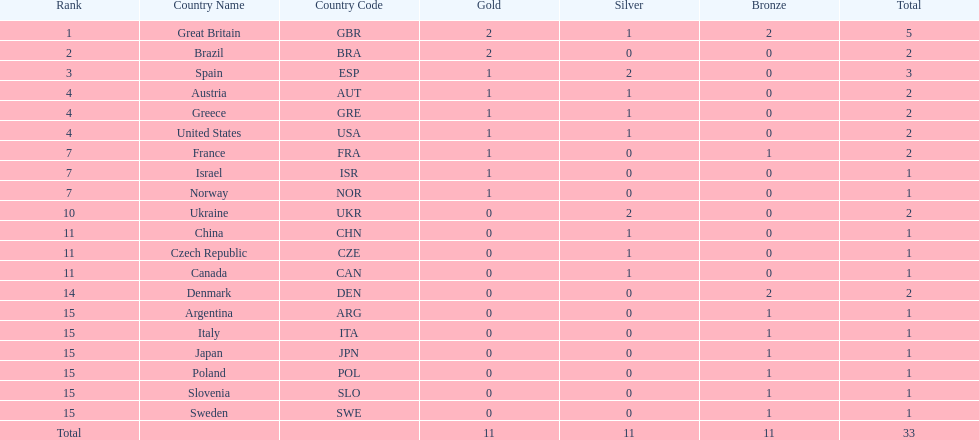Which country won the most medals total? Great Britain (GBR). 